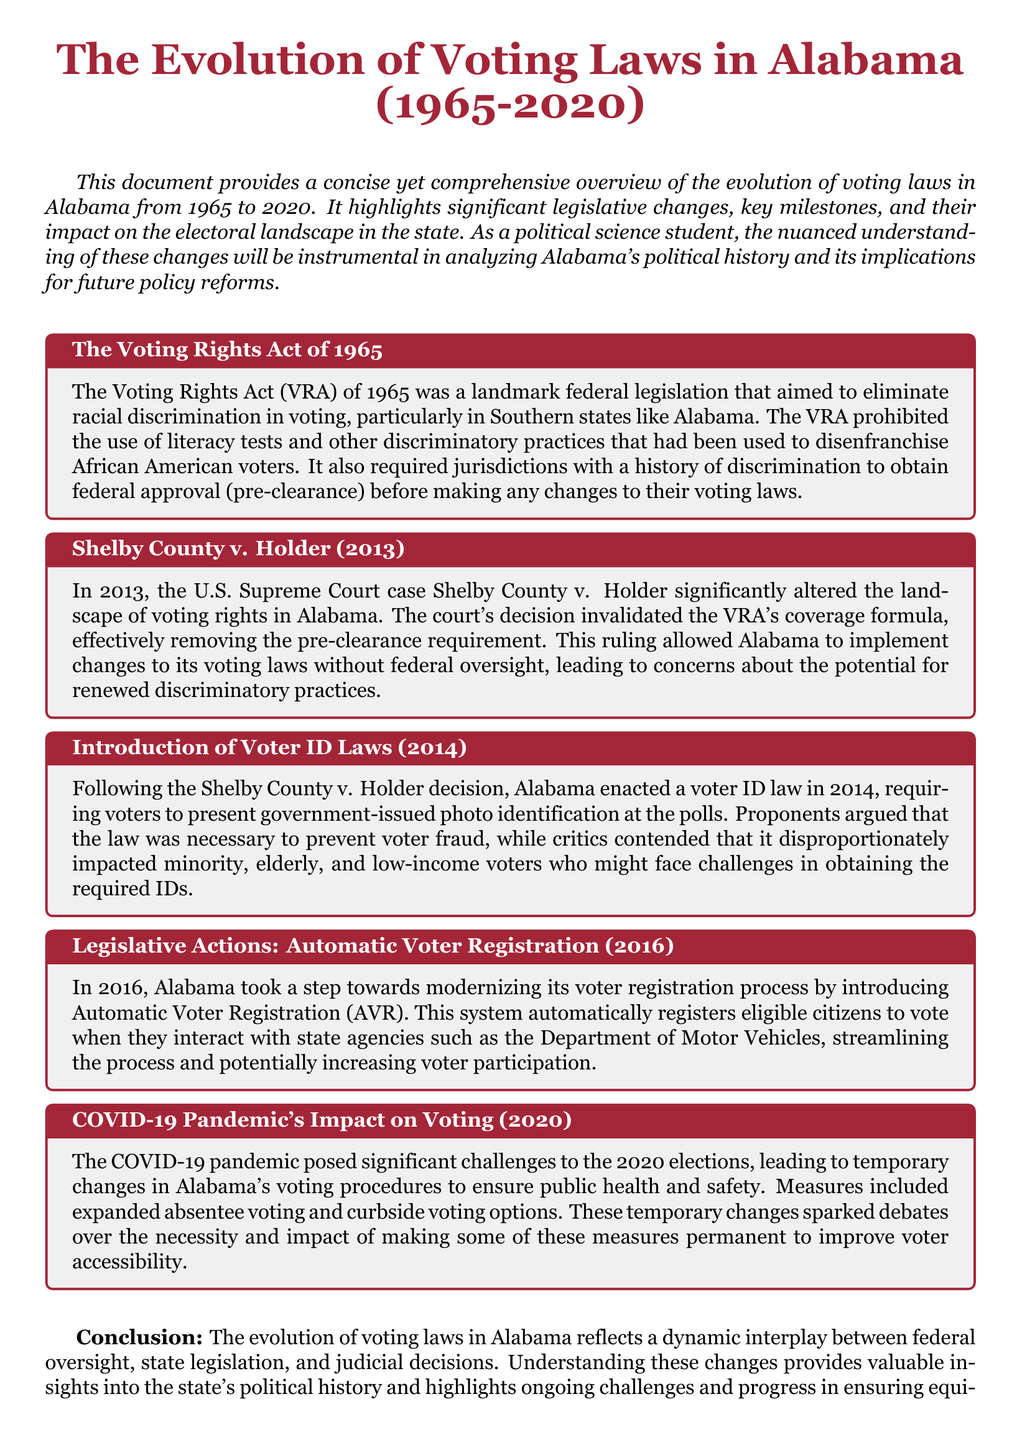What year was the Voting Rights Act enacted? The document states that the Voting Rights Act (VRA) was a landmark federal legislation that aimed to eliminate racial discrimination in voting, and it was enacted in 1965.
Answer: 1965 What significant court case altered voting rights in Alabama? The document mentions Shelby County v. Holder as a significant U.S. Supreme Court case that changed voting rights in Alabama.
Answer: Shelby County v. Holder What requirement was removed by the Shelby County v. Holder decision? The ruling in Shelby County v. Holder invalidated the VRA's coverage formula, effectively removing the pre-clearance requirement for Alabama.
Answer: Pre-clearance requirement When did Alabama introduce voter ID laws? According to the document, Alabama enacted a voter ID law in 2014, following a significant court ruling related to voting rights.
Answer: 2014 What does Automatic Voter Registration aim to streamline? The document indicates that Automatic Voter Registration aims to streamline the voter registration process by automatically registering eligible citizens.
Answer: Voter registration process What temporary changes were influenced by the COVID-19 pandemic? The pandemic led to temporary changes in Alabama's voting procedures, including expanded absentee voting and curbside voting options.
Answer: Expanded absentee voting and curbside voting What was a concern regarding the 2014 voter ID law? Critics contended that the voter ID law disproportionately impacted minority, elderly, and low-income voters, raising concerns about its fairness.
Answer: Disproportionate impact on minority, elderly, and low-income voters What legislative measure was implemented in 2016? The document states that Alabama introduced Automatic Voter Registration in 2016, aimed at modernizing its voter registration process.
Answer: Automatic Voter Registration What was a key outcome of the evolution of voting laws in Alabama? The evolution of voting laws reflects a dynamic interplay between federal oversight, state legislation, and judicial decisions, highlighting ongoing challenges in voting access.
Answer: Dynamic interplay between federal oversight, state legislation, and judicial decisions 